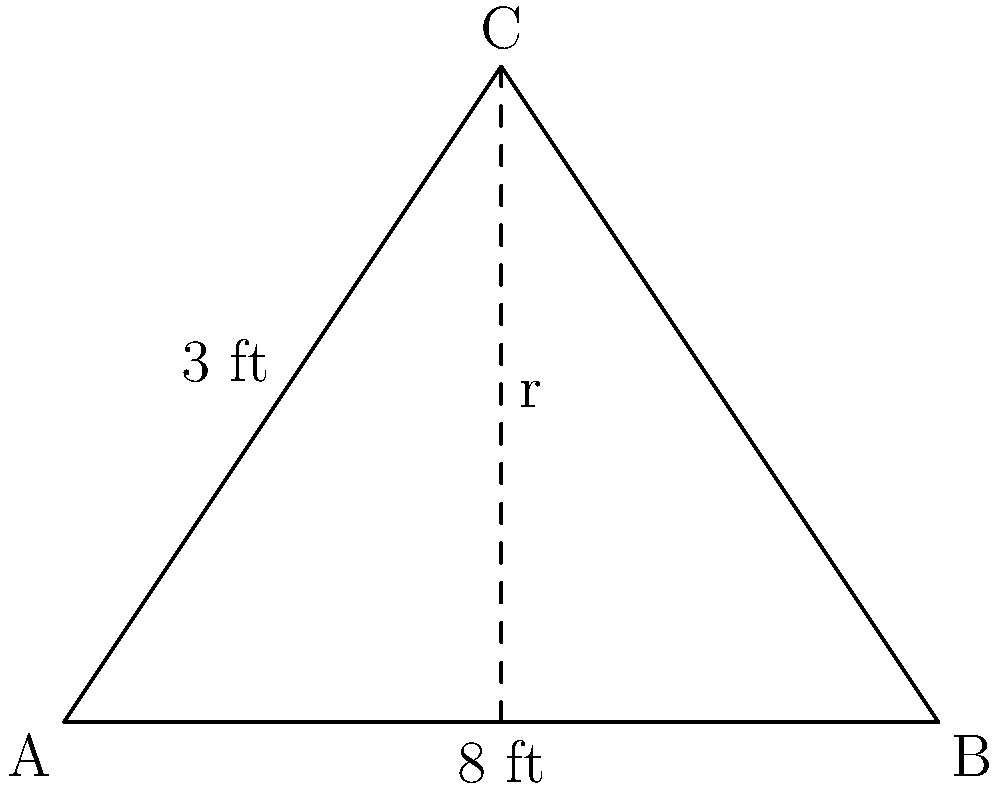A beachfront restaurant in Laguna Beach uses conical umbrellas to shade its outdoor seating area. Each umbrella has a base diameter of 8 feet and a height of 3 feet. What is the surface area of the fabric covering the umbrella, excluding the circular base? Round your answer to the nearest square foot. To find the surface area of the conical umbrella, we need to calculate the lateral surface area of a cone. Let's approach this step-by-step:

1) First, we need to find the slant height (s) of the cone using the Pythagorean theorem:

   $$s^2 = r^2 + h^2$$

   where r is the radius of the base and h is the height of the cone.

2) The radius (r) is half the diameter, so r = 4 ft.
   The height (h) is given as 3 ft.

3) Plugging these into the formula:

   $$s^2 = 4^2 + 3^2 = 16 + 9 = 25$$

4) Taking the square root:

   $$s = \sqrt{25} = 5 \text{ ft}$$

5) Now that we have the slant height, we can calculate the lateral surface area using the formula:

   $$A = \pi r s$$

6) Substituting the values:

   $$A = \pi \cdot 4 \cdot 5 = 20\pi \text{ sq ft}$$

7) Calculating and rounding to the nearest square foot:

   $$20\pi \approx 62.83 \text{ sq ft} \approx 63 \text{ sq ft}$$

Therefore, the surface area of the fabric covering the umbrella is approximately 63 square feet.
Answer: 63 sq ft 